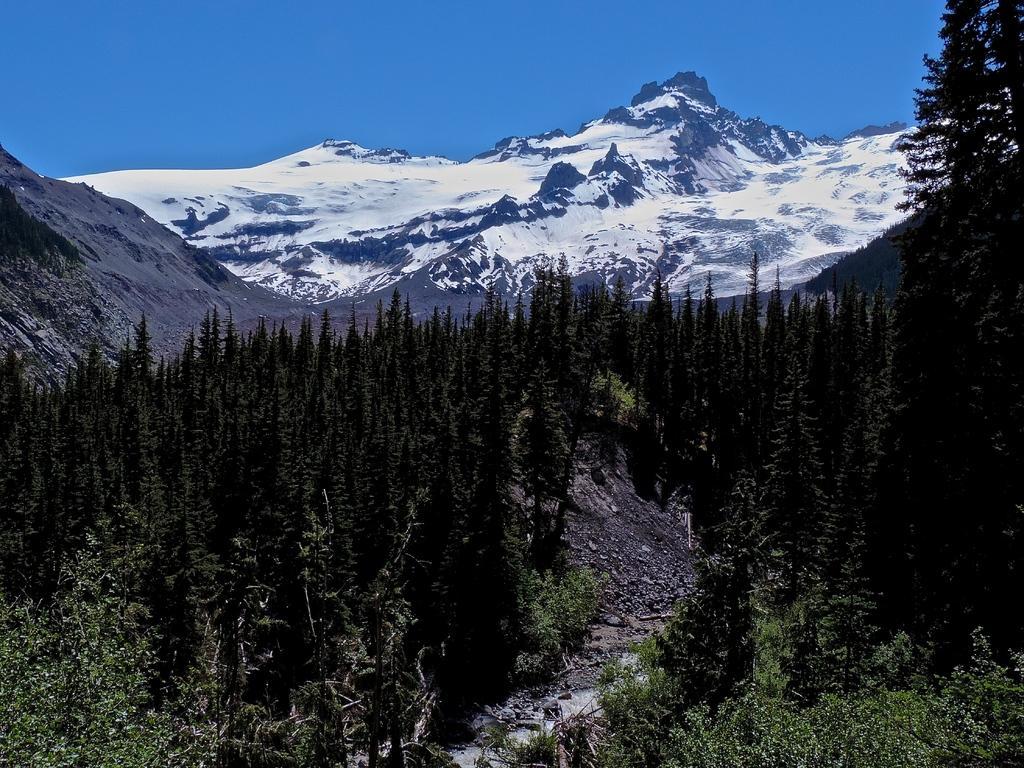Describe this image in one or two sentences. At the bottom of the picture, there are many trees. In the background, there are hills which are covered with ice. At the top of the picture, we see the sky, which is blue in color. 